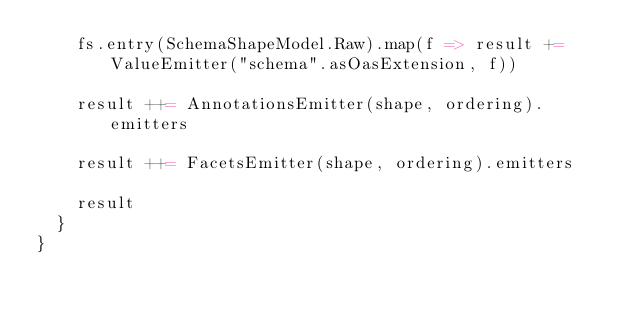Convert code to text. <code><loc_0><loc_0><loc_500><loc_500><_Scala_>    fs.entry(SchemaShapeModel.Raw).map(f => result += ValueEmitter("schema".asOasExtension, f))

    result ++= AnnotationsEmitter(shape, ordering).emitters

    result ++= FacetsEmitter(shape, ordering).emitters

    result
  }
}
</code> 